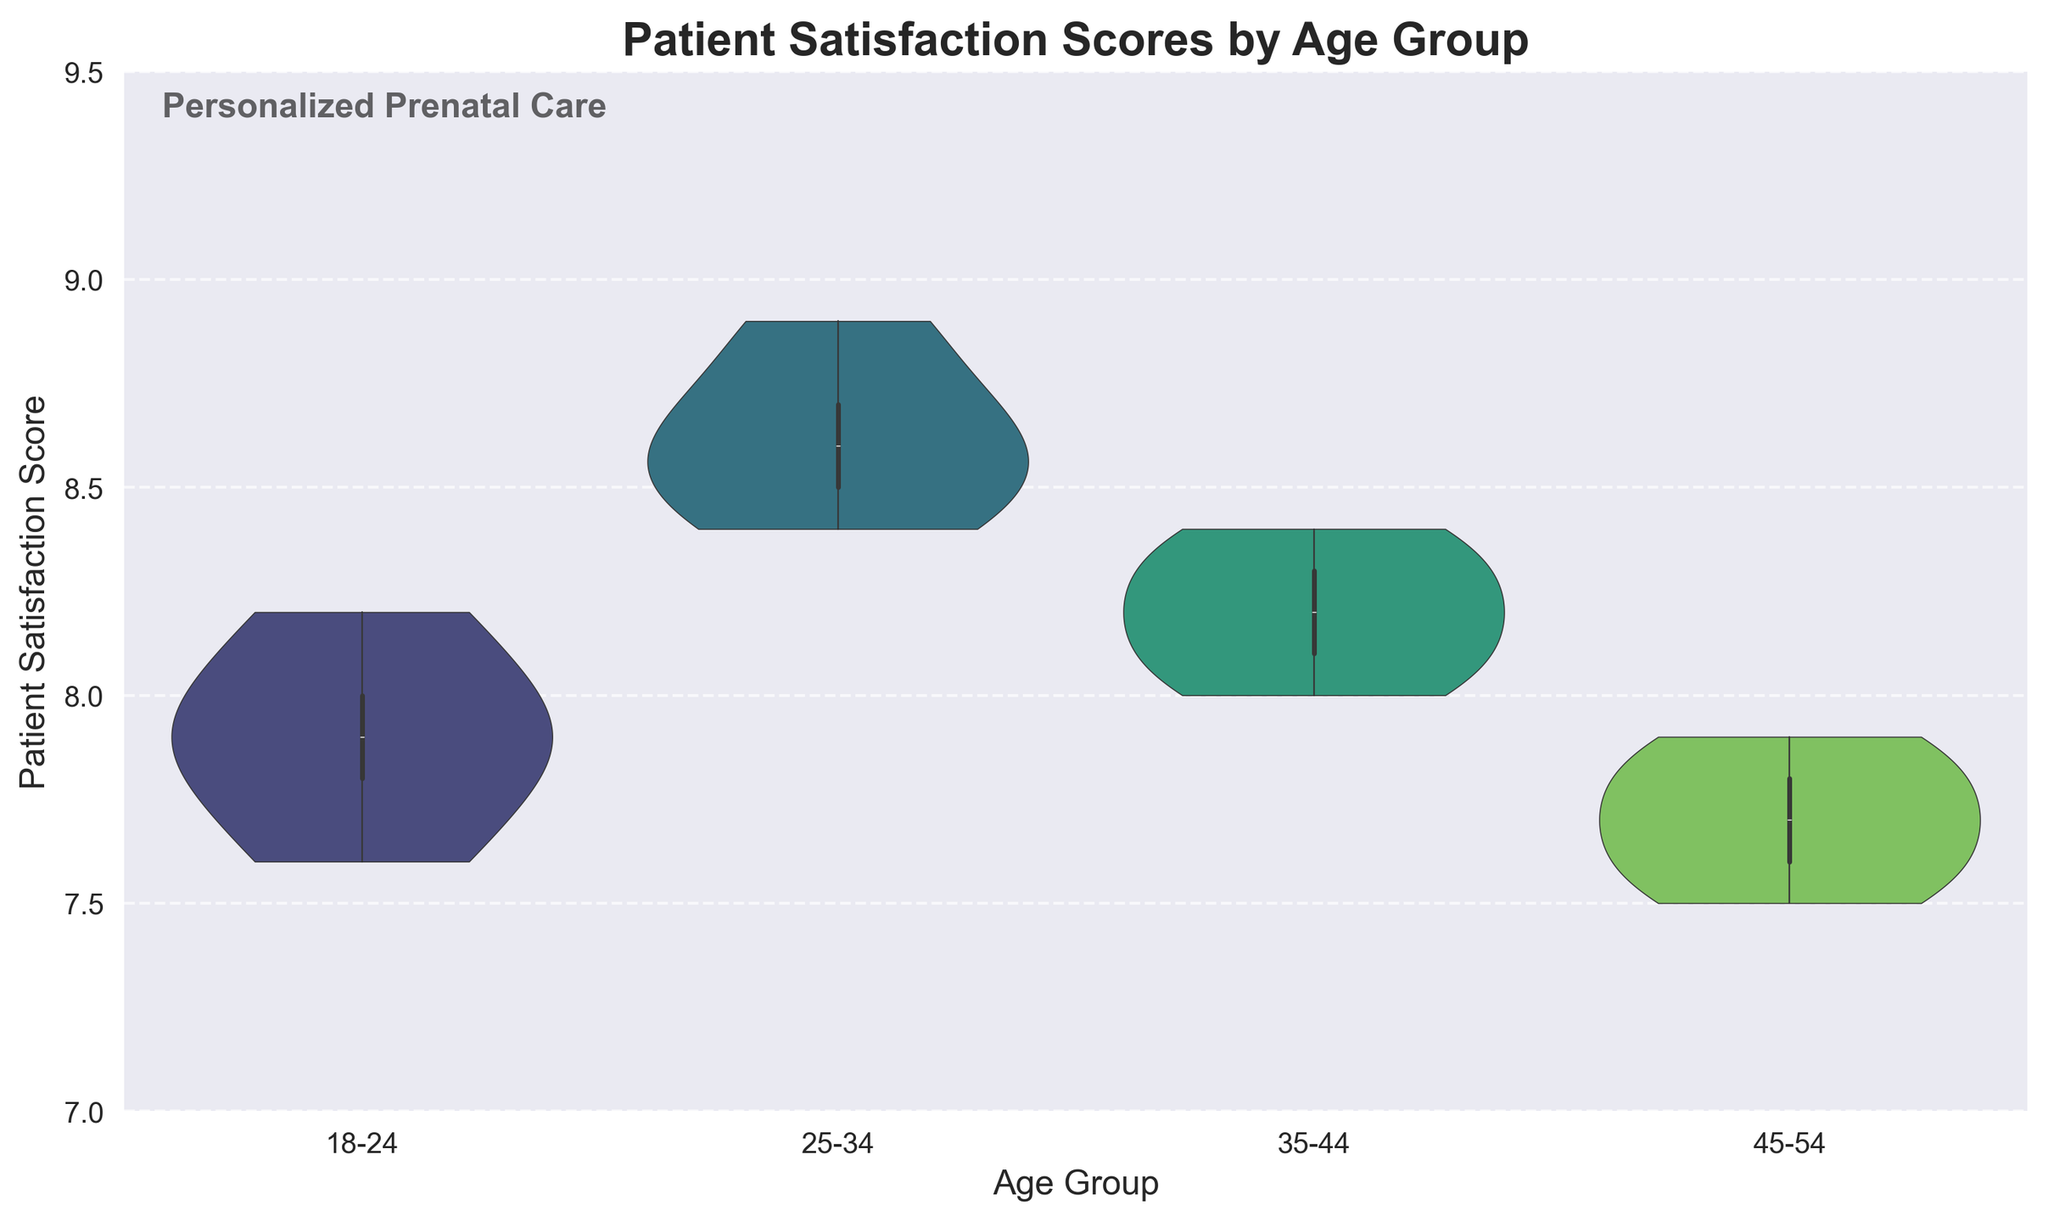What is the title of the figure? The title is usually located at the top of the figure, specifying the content of the chart. Here, it states the context of the data displayed.
Answer: Patient Satisfaction Scores by Age Group Which age group has the highest median satisfaction score? Looking at the inner box of each violin plot, the median is represented by the line inside the box. The highest median line is observed in the '25-34' age group.
Answer: 25-34 What is the range of satisfaction scores for the '45-54' age group? The range can be determined by looking at the top and bottom of the violin plot. For the '45-54' age group, it ranges from 7.5 to 7.9.
Answer: 7.5 to 7.9 How do the average satisfaction scores compare between the 18-24 and 35-44 age groups? To compare the averages, note the widths and locations of the violin plots. The '35-44' age group has a slightly higher average satisfaction score than the '18-24' group.
Answer: 35-44 has a slightly higher average What is the interquartile range (IQR) of the satisfaction scores for the '25-34' age group? The IQR is the range between the first quartile (bottom of the box) and the third quartile (top of the box). For '25-34', this appears to be from around 8.4 to 8.7.
Answer: 8.4 to 8.7 Which age group shows the most variability in satisfaction scores? Variability is indicated by the spread and width of the violin plot. The widest and most spread out plot appears to be for the '18-24' age group.
Answer: 18-24 Are there any age groups with outliers in their satisfaction scores? Outliers are usually represented as dots outside the main body of the violin plot. Based on the figure, no outliers are visible in any age group.
Answer: No Describe the shape of the satisfaction score distribution for the '25-34' age group. The shape can be described by observing the symmetry and width of the violin plot. The '25-34' group has a fairly symmetrical distribution with slight peaks near the median.
Answer: Symmetrical with slight peaks near the median Which age group has the narrowest range of satisfaction scores? The narrowest range is determined by the least vertical spread in the violin plot. The '45-54' age group has the narrowest range from 7.5 to about 7.9.
Answer: 45-54 What general trend can be observed regarding patient satisfaction and age? Observing all the plots collectively, satisfaction seems to generally peak in the '25-34' group and slightly decrease in older age groups.
Answer: Peaks in the '25-34' group, then decreases 